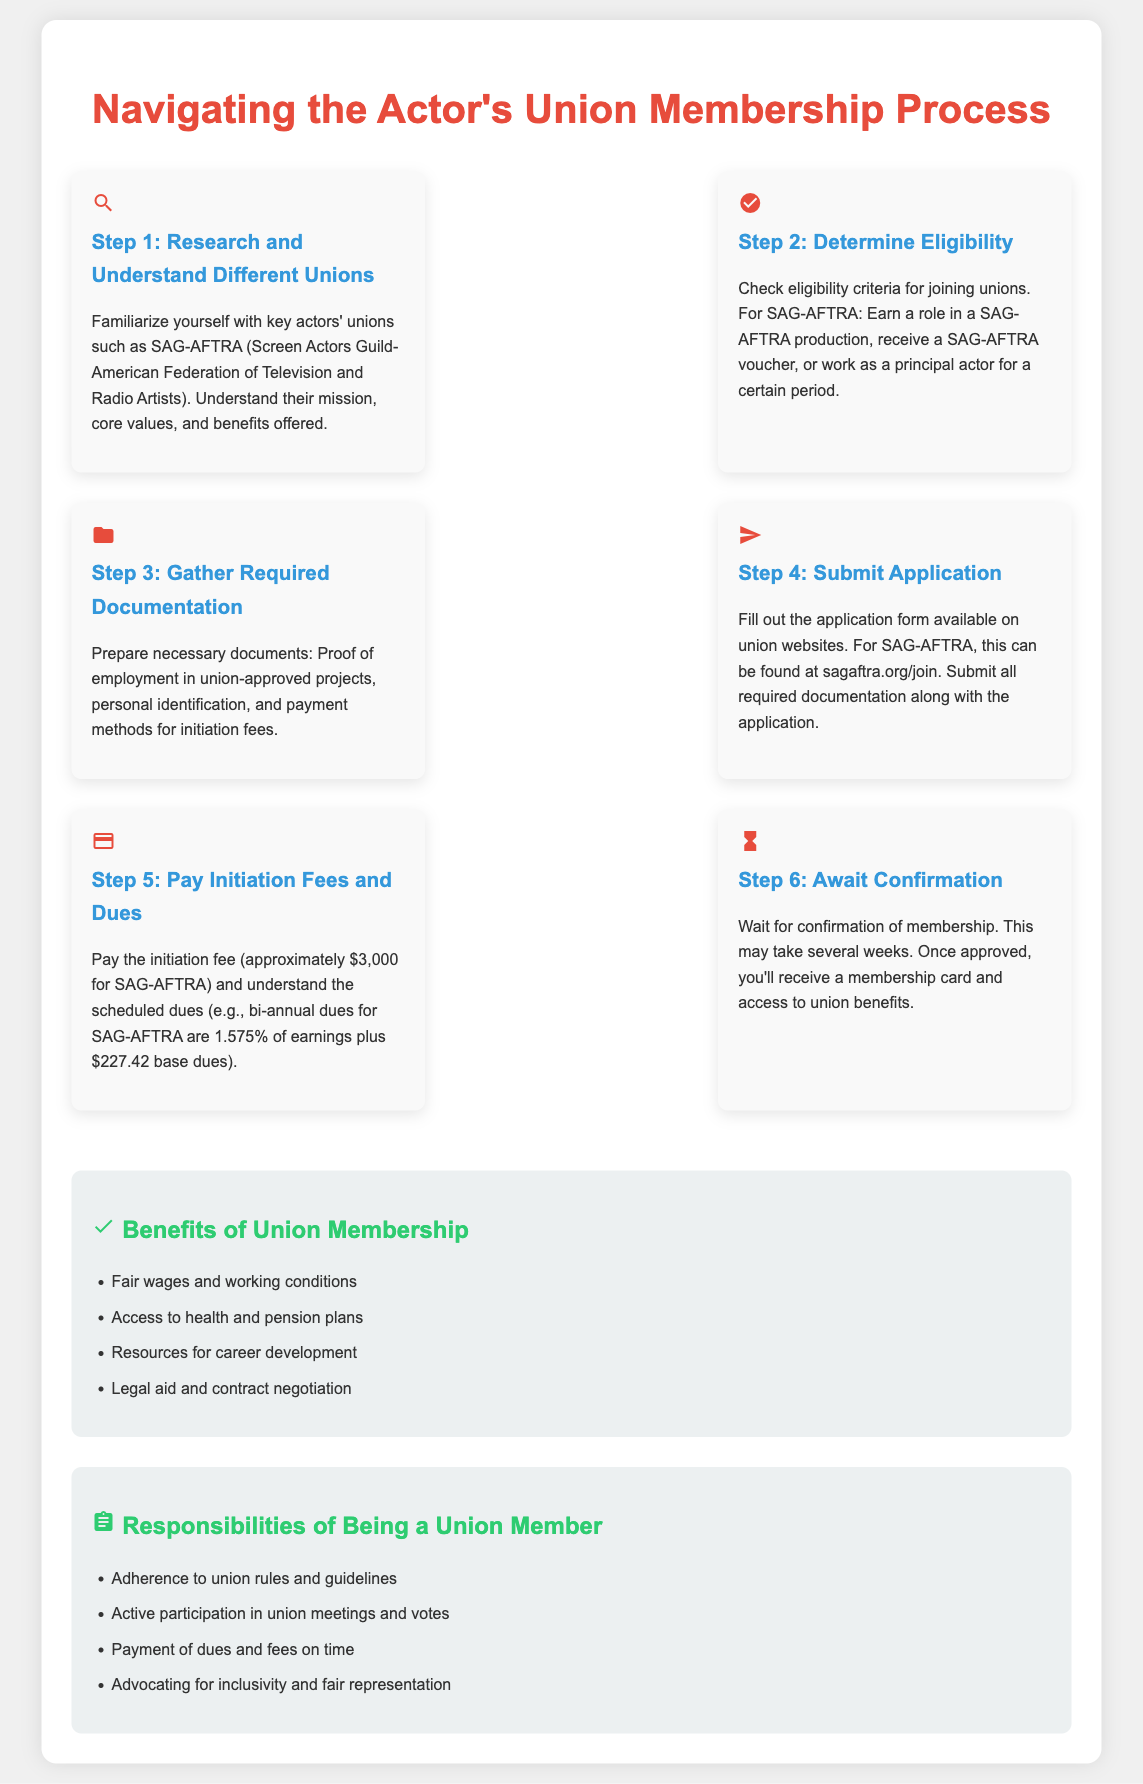what is the first step in the membership process? The first step involves familiarizing oneself with key actors' unions such as SAG-AFTRA and understanding their mission and benefits.
Answer: Research and Understand Different Unions what is the initiation fee for SAG-AFTRA? The initiation fee required for SAG-AFTRA membership is mentioned as approximately $3,000.
Answer: $3,000 what is one benefit of union membership? The document lists several benefits, one of which includes access to health and pension plans.
Answer: Access to health and pension plans what must you gather before submitting an application? Before submitting an application, necessary documents must be prepared, including proof of employment in union-approved projects.
Answer: Required Documentation what percentage of earnings is associated with SAG-AFTRA's scheduled dues? The scheduled dues for SAG-AFTRA are 1.575% of earnings, as stated in the document.
Answer: 1.575% why is waiting for confirmation important? Waiting for confirmation is important because it allows the applicant to receive their membership card and access union benefits.
Answer: Confirmation of membership what document should you check to determine eligibility? You should check the eligibility criteria for joining unions, which may vary by each union.
Answer: Eligibility criteria name one responsibility of being a union member. The document outlines several responsibilities, including active participation in union meetings and votes.
Answer: Active participation in union meetings what type of document is this? The content is structured to provide steps and information related to the membership process for actors' unions.
Answer: Process infographic 